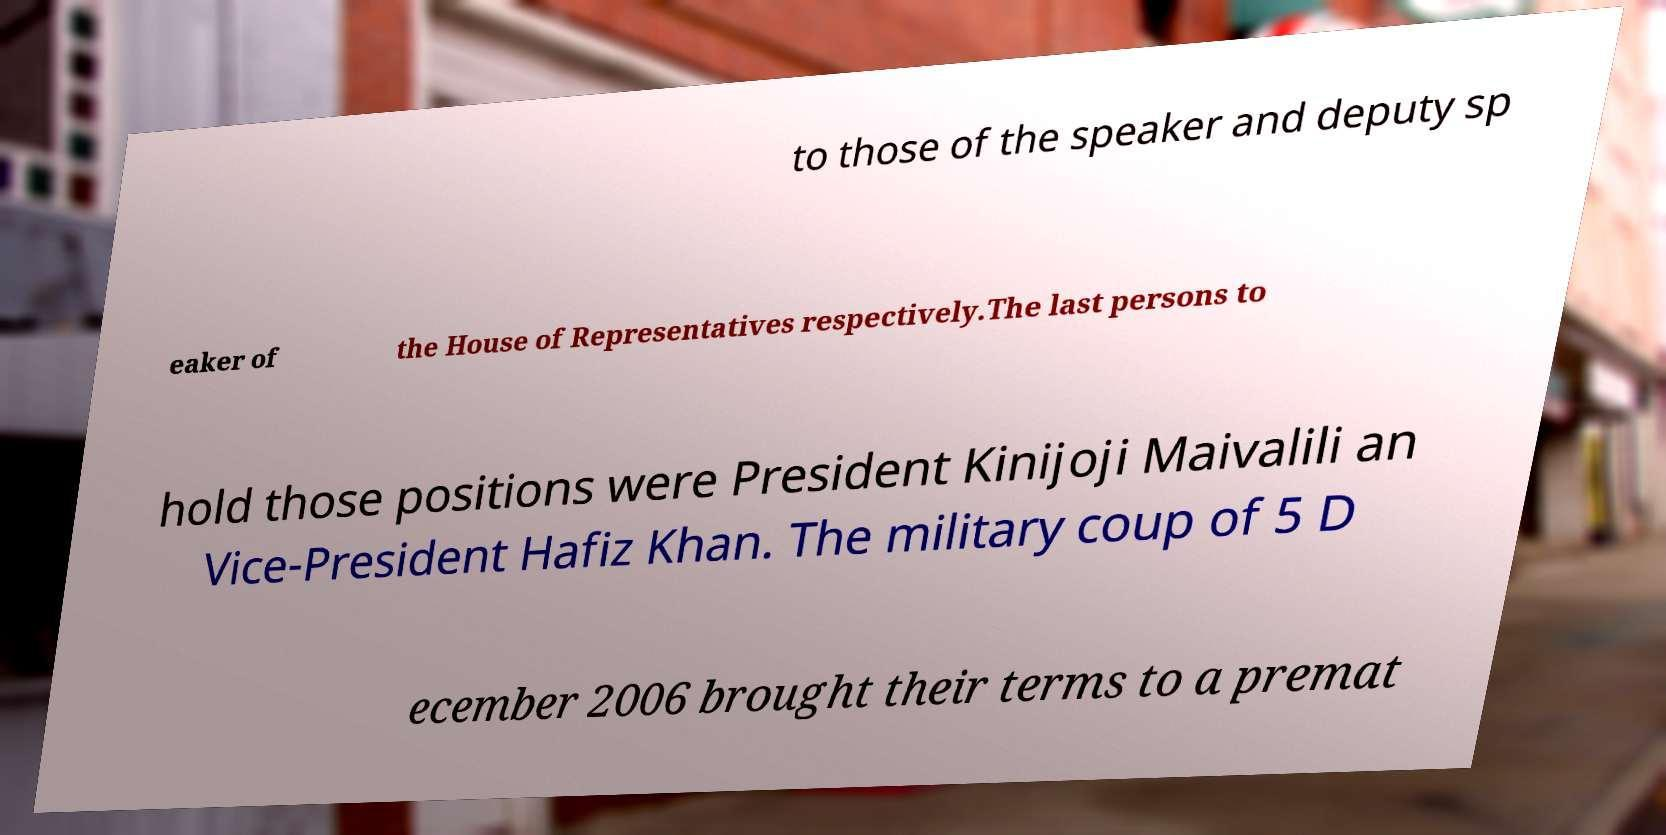Please read and relay the text visible in this image. What does it say? to those of the speaker and deputy sp eaker of the House of Representatives respectively.The last persons to hold those positions were President Kinijoji Maivalili an Vice-President Hafiz Khan. The military coup of 5 D ecember 2006 brought their terms to a premat 